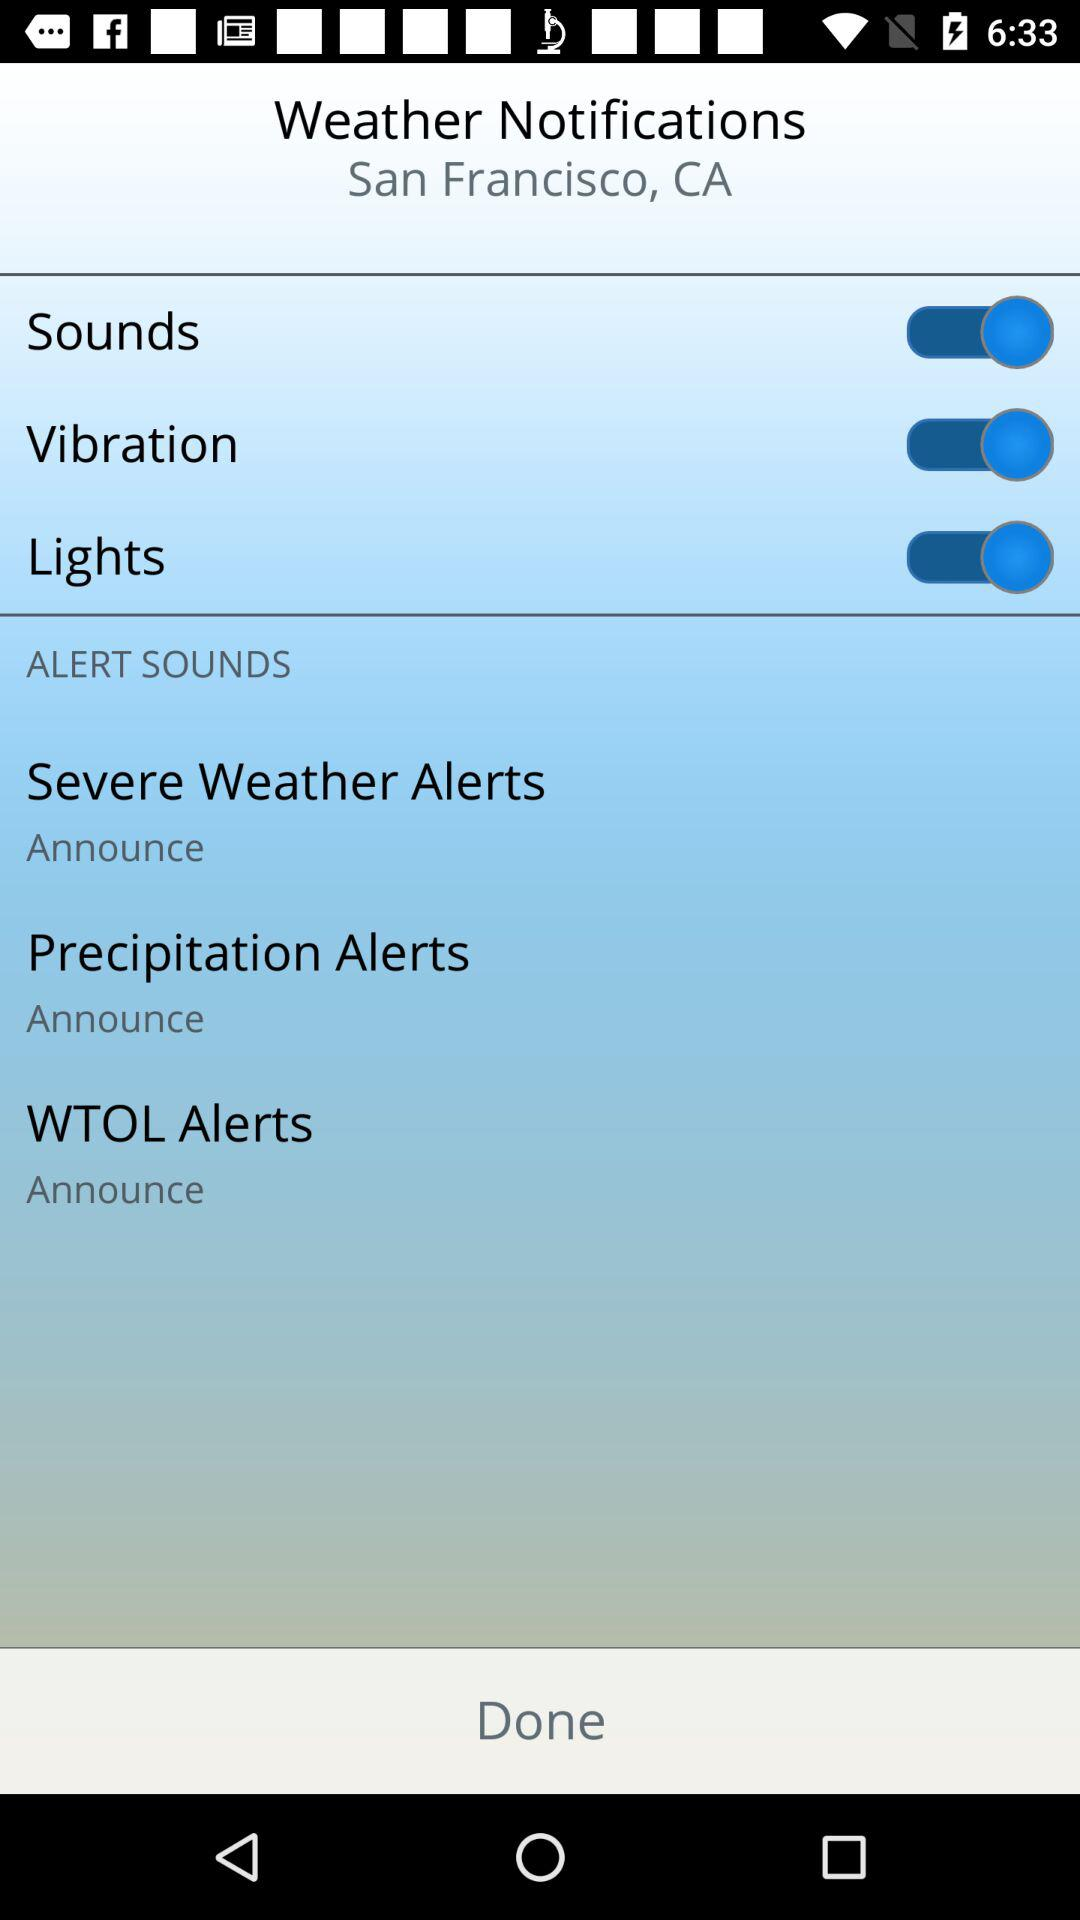What is the setting for "WTOL Alerts"? The setting for "WTOL Alerts" is "Announce". 